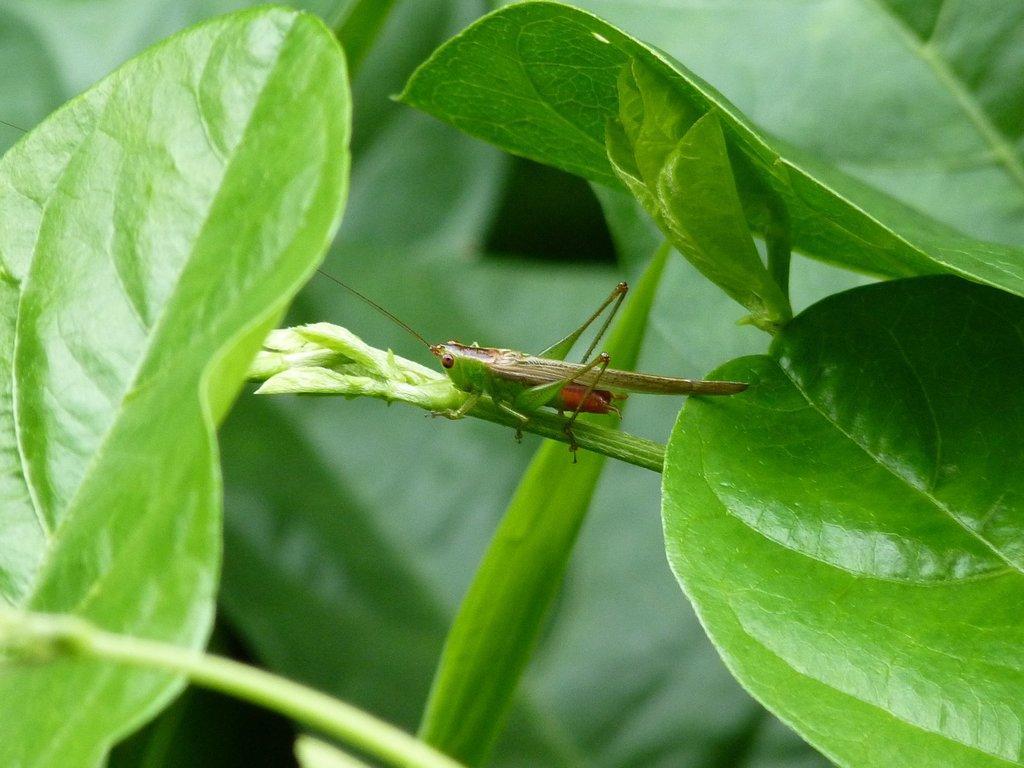Please provide a concise description of this image. This picture contains a plant. In the middle of the picture, we see a grasshopper is on the plant. Beside that, we see leaves which are in green color. 